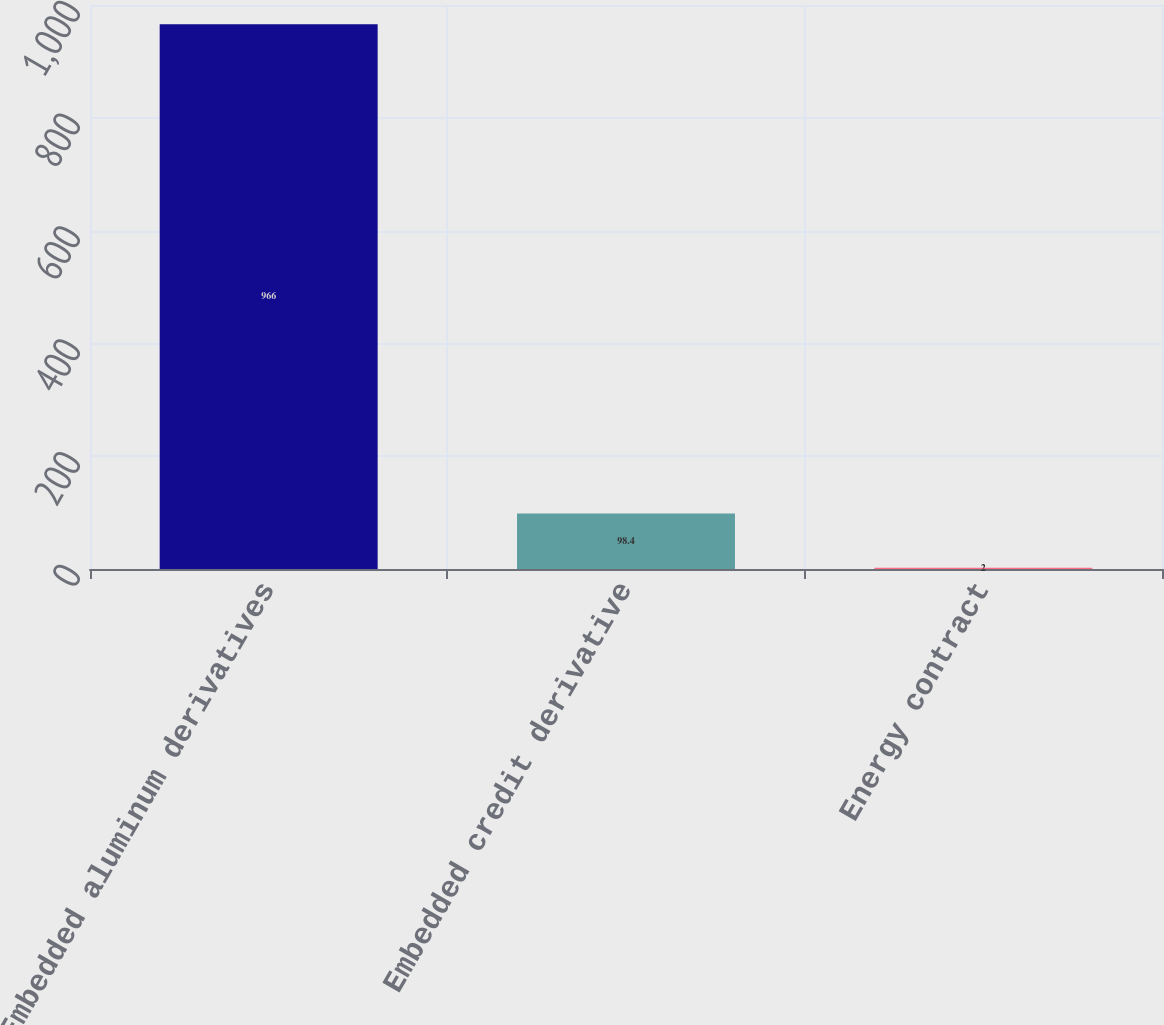<chart> <loc_0><loc_0><loc_500><loc_500><bar_chart><fcel>Embedded aluminum derivatives<fcel>Embedded credit derivative<fcel>Energy contract<nl><fcel>966<fcel>98.4<fcel>2<nl></chart> 